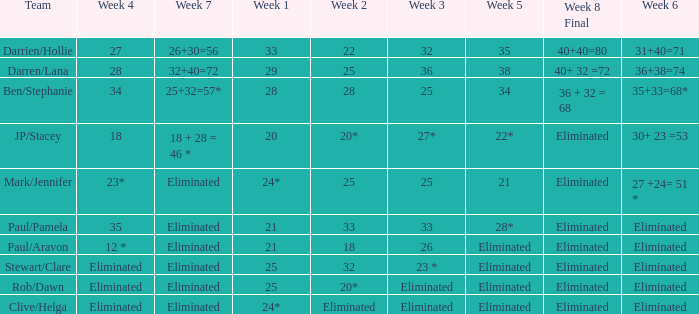Name the team for week 1 of 28 Ben/Stephanie. 